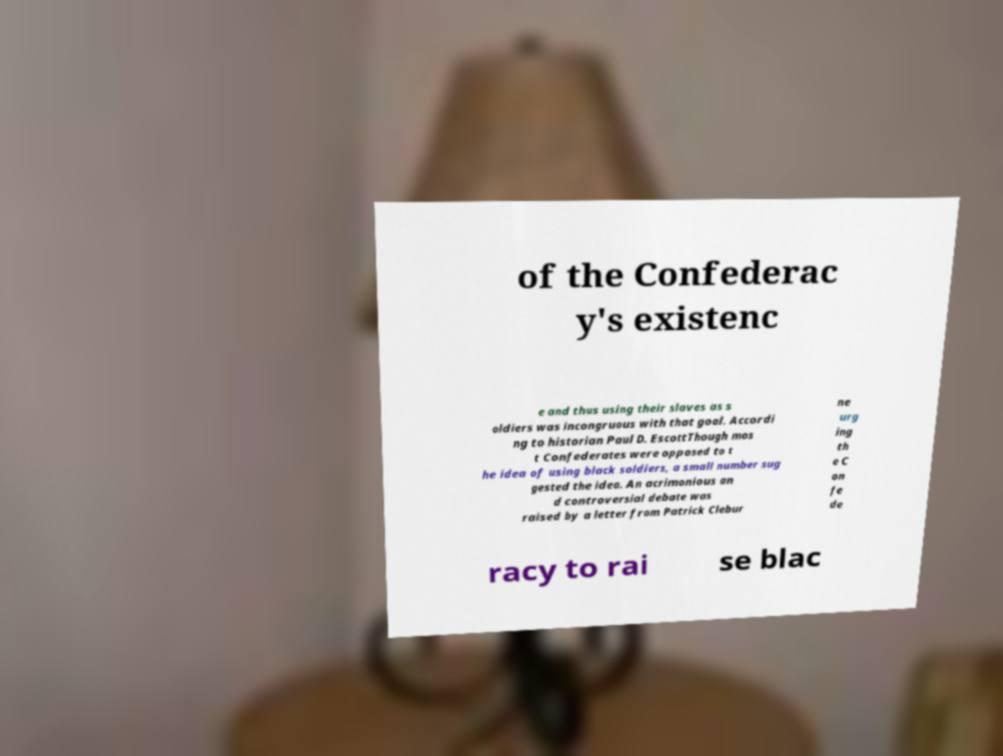Could you extract and type out the text from this image? of the Confederac y's existenc e and thus using their slaves as s oldiers was incongruous with that goal. Accordi ng to historian Paul D. EscottThough mos t Confederates were opposed to t he idea of using black soldiers, a small number sug gested the idea. An acrimonious an d controversial debate was raised by a letter from Patrick Clebur ne urg ing th e C on fe de racy to rai se blac 